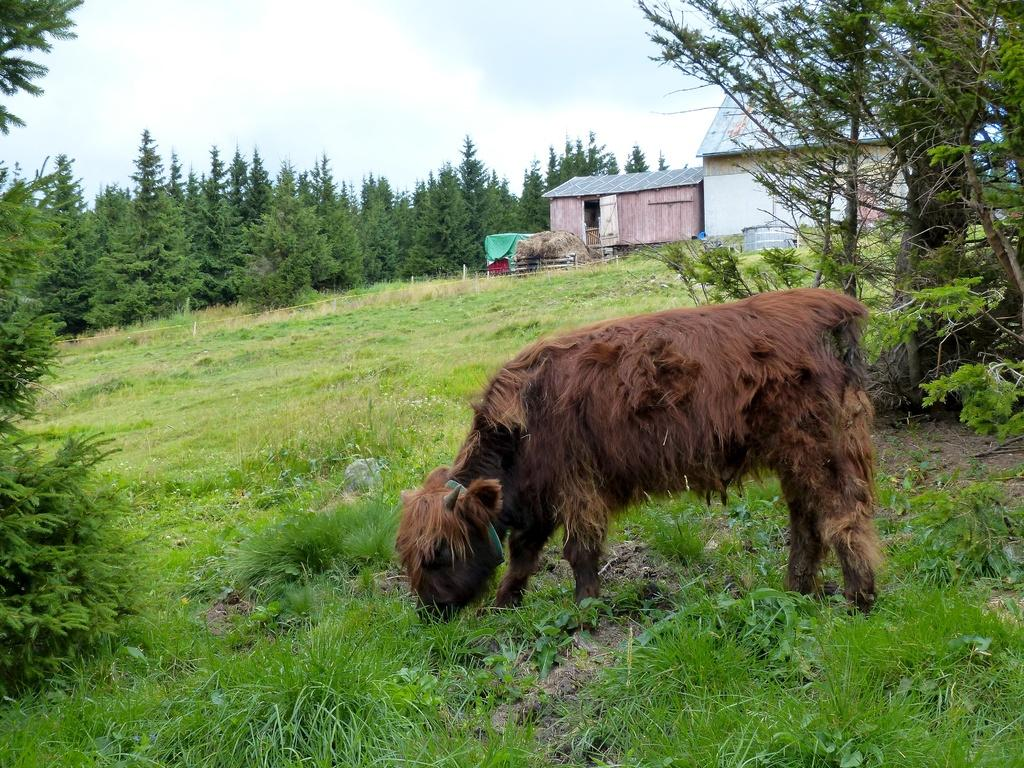What is the main subject in the center of the image? There is a cow in the center of the image. What type of vegetation is at the bottom of the image? There is grass at the bottom of the image. What can be seen in the background of the image? There are trees and a house in the background of the image. What part of the natural environment is visible in the image? The sky is visible in the image. What type of trousers is the beggar wearing in the image? There is no beggar present in the image, so it is not possible to determine what type of trousers they might be wearing. 